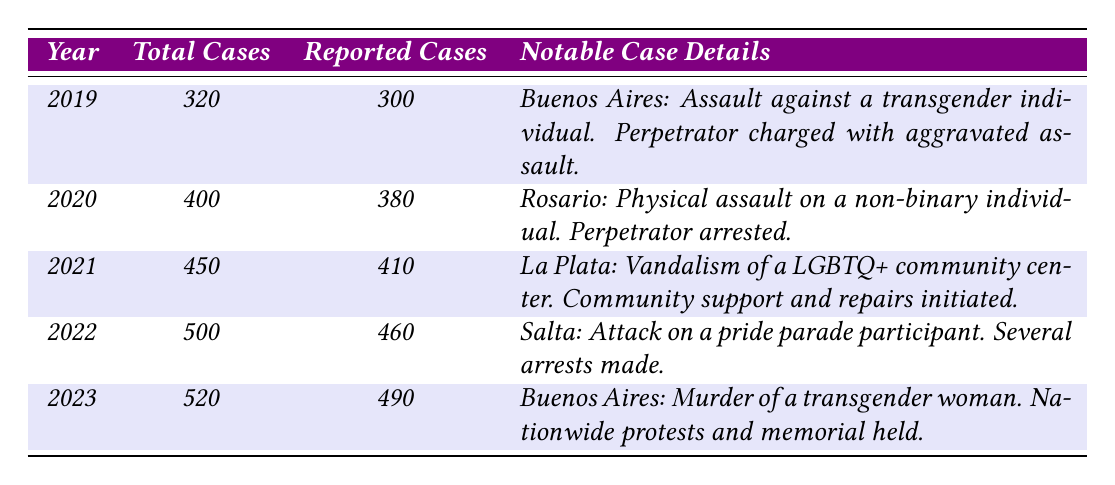What was the total number of gender-related hate crime cases reported in Argentina in 2021? In the table, under the year 2021, the total number of cases listed is 450.
Answer: 450 How many reported cases of gender-related hate crimes were there in 2020? The table indicates that for the year 2020, there were 380 reported cases.
Answer: 380 Which city had a notable incident involving physical assault on a non-binary individual in 2020? By examining the case details for 2020, the incident of physical assault on a non-binary individual happened in Rosario.
Answer: Rosario What was the outcome of the attack on a pride parade participant in Salta in 2022? The table states that the outcome was that several arrests were made following the attack on a pride parade participant in Salta.
Answer: Several arrests made What is the difference between total cases in 2022 and 2023? The table shows that in 2022 there were 500 total cases and in 2023 there were 520 total cases. The difference is 520 - 500 = 20.
Answer: 20 In which year did the murder of a transgender woman result in nationwide protests and memorials? According to the table, the murder of a transgender woman in Buenos Aires led to nationwide protests and memorials in 2023.
Answer: 2023 Is it true that the total number of reported cases increased every year from 2019 to 2023? Looking at the reported cases: 300 in 2019, 380 in 2020, 410 in 2021, 460 in 2022, and 490 in 2023, it shows a consistent increase each year. Therefore, the statement is true.
Answer: True What was the average number of reported cases from 2019 to 2023? The reported cases from 2019 to 2023 are: 300, 380, 410, 460, and 490. The sum is 300 + 380 + 410 + 460 + 490 = 2040. There are 5 data points, so the average is 2040 / 5 = 408.
Answer: 408 How many cases were reported in total from 2019 to 2021? The reported cases from 2019 to 2021 are: 300 for 2019, 380 for 2020, and 410 for 2021. The total reported cases for these years is 300 + 380 + 410 = 1090.
Answer: 1090 What notable case occurred in La Plata in 2021? The table indicates that in La Plata in 2021, there was vandalism of a LGBTQ+ community center, and community support and repairs were initiated as an outcome.
Answer: Vandalism of a LGBTQ+ community center 